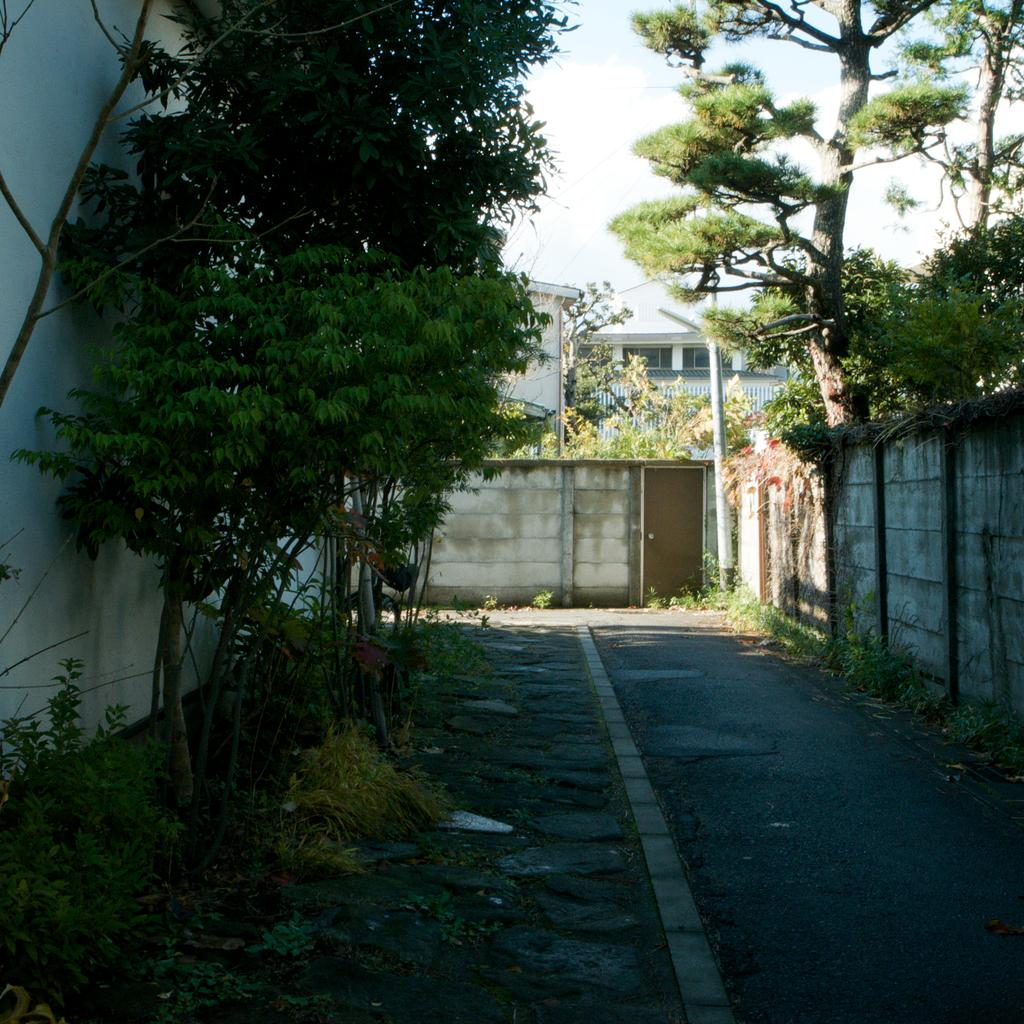What type of vegetation is on the left side of the image? There are trees on the left side of the image. What can be seen on the right side of the image? There is a wall and trees on the right side of the image. What is in the middle of the image? There is a path in the middle of the image. What is visible in the background of the image? There is a wall, trees, buildings, and the sky visible in the background of the image. Can you tell me how many swings are hanging from the trees in the image? There are no swings present in the image; it features trees, a path, and a wall. What type of snake can be seen slithering across the wall in the image? There is no snake present in the image; it features trees, a path, and a wall. 